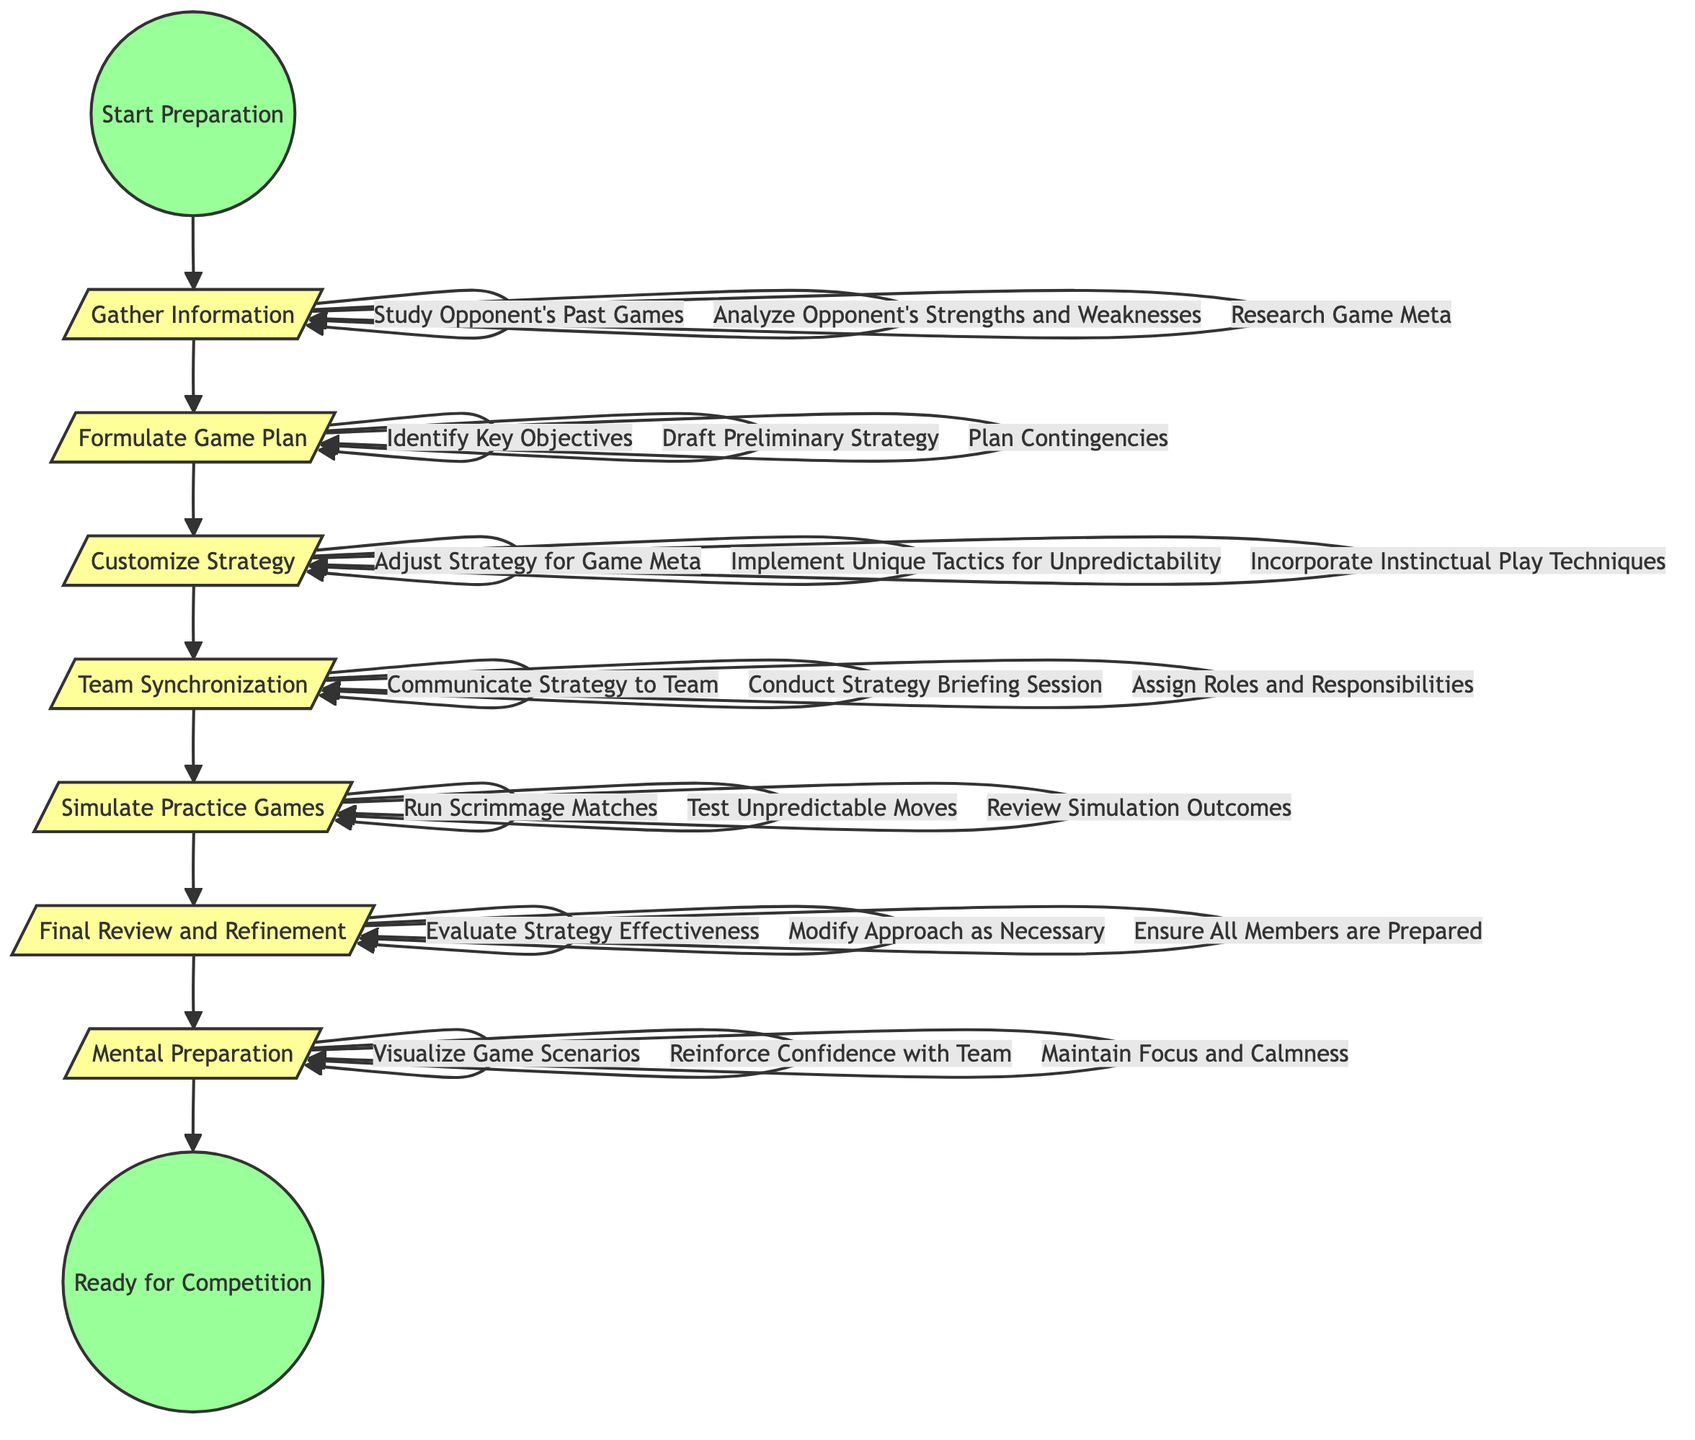What is the starting point of the activity diagram? The diagram begins with the node labeled "Start Preparation." This is clearly indicated as the first activity in the diagram, leading to the next step, which is to gather information.
Answer: Start Preparation How many main activities are in the diagram? The diagram includes six main activities: Gather Information, Formulate Game Plan, Customize Strategy, Team Synchronization, Simulate Practice Games, and Final Review and Refinement. By counting these nodes in the diagram, we find there are six distinct activities.
Answer: 6 Which activity comes after 'Customize Strategy'? The activity that follows 'Customize Strategy' in the flow of the diagram is 'Team Synchronization.' This is a direct progression indicated by the arrows leading from one activity to the next.
Answer: Team Synchronization What action is associated with 'Gather Information'? One of the actions associated with 'Gather Information' is 'Analyze Opponent's Strengths and Weaknesses.' This is one of the specific actions listed under the 'Gather Information' activity in the diagram.
Answer: Analyze Opponent's Strengths and Weaknesses What is the last activity before reaching "Ready for Competition"? The last activity before reaching "Ready for Competition" is 'Mental Preparation.' The diagram shows the flow leading into this final step before concluding the preparation process.
Answer: Mental Preparation What actions can be taken in the 'Simulate Practice Games' activity? The actions that can be undertaken in 'Simulate Practice Games' include 'Run Scrimmage Matches,' 'Test Unpredictable Moves,' and 'Review Simulation Outcomes.' These actions are listed under this activity in the diagram.
Answer: Run Scrimmage Matches, Test Unpredictable Moves, Review Simulation Outcomes How is 'Final Review and Refinement' connected to the previous activity? 'Final Review and Refinement' is directly connected to 'Simulate Practice Games' through a downward arrow, indicating that once the practice games are simulated, the next step is to review and refine the strategies based on those simulations.
Answer: By an arrow What is the purpose of 'Mental Preparation'? The purpose of 'Mental Preparation' is to help players visualize game scenarios, reinforce confidence with the team, and maintain focus and calmness, ensuring they are mentally ready for competition. Each listed action serves to enhance psychological readiness.
Answer: Enhance psychological readiness 